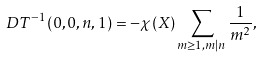Convert formula to latex. <formula><loc_0><loc_0><loc_500><loc_500>\ D T ^ { - 1 } ( 0 , 0 , n , 1 ) = - \chi ( X ) \sum _ { m \geq 1 , m | n } \frac { 1 } { m ^ { 2 } } ,</formula> 